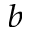Convert formula to latex. <formula><loc_0><loc_0><loc_500><loc_500>^ { b }</formula> 